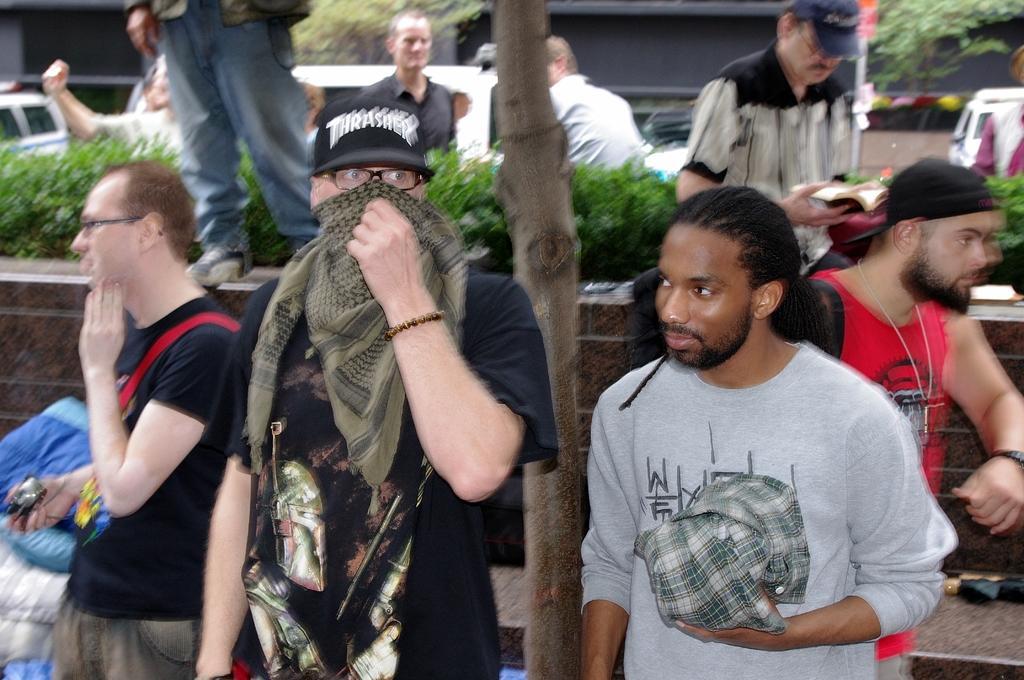In one or two sentences, can you explain what this image depicts? In this image I can see number of people are standing. I can see most of them are wearing caps and here I can see few of them are wearing specs. I can also see plants, vehicles, trees and I can see this image is little bit blurry. 